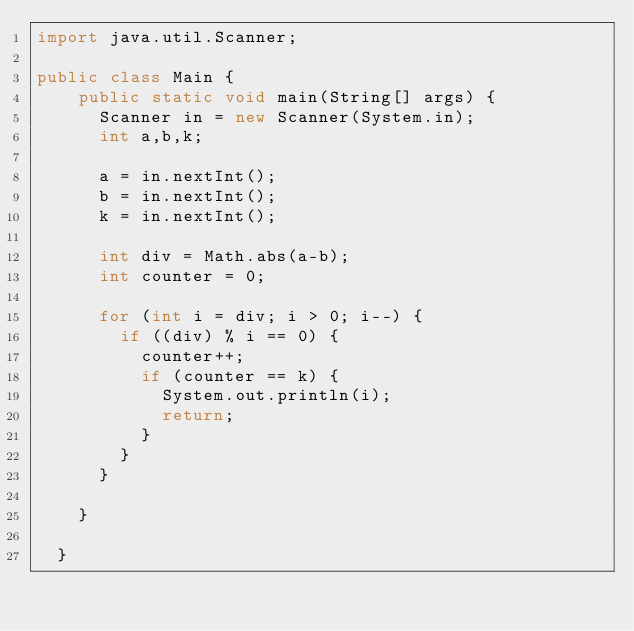<code> <loc_0><loc_0><loc_500><loc_500><_Java_>import java.util.Scanner;

public class Main {
    public static void main(String[] args) {
    	Scanner in = new Scanner(System.in);
    	int a,b,k;
    	
    	a = in.nextInt();
    	b = in.nextInt();
    	k = in.nextInt();
    	
    	int div = Math.abs(a-b);
    	int counter = 0;
    	
    	for (int i = div; i > 0; i--) {
    		if ((div) % i == 0) {
    			counter++;
    			if (counter == k) {
    				System.out.println(i);
    				return;
    			}
    		}
    	}
    	
    }

  }
</code> 